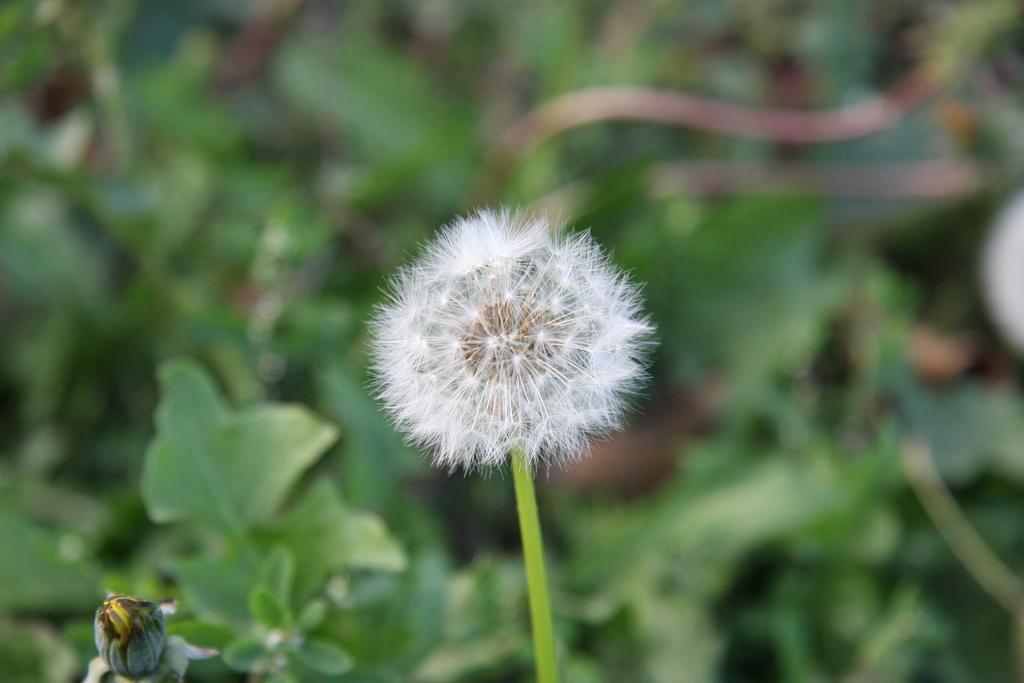How would you summarize this image in a sentence or two? In this picture I can see a flower It is white in color and I can see few plants. 